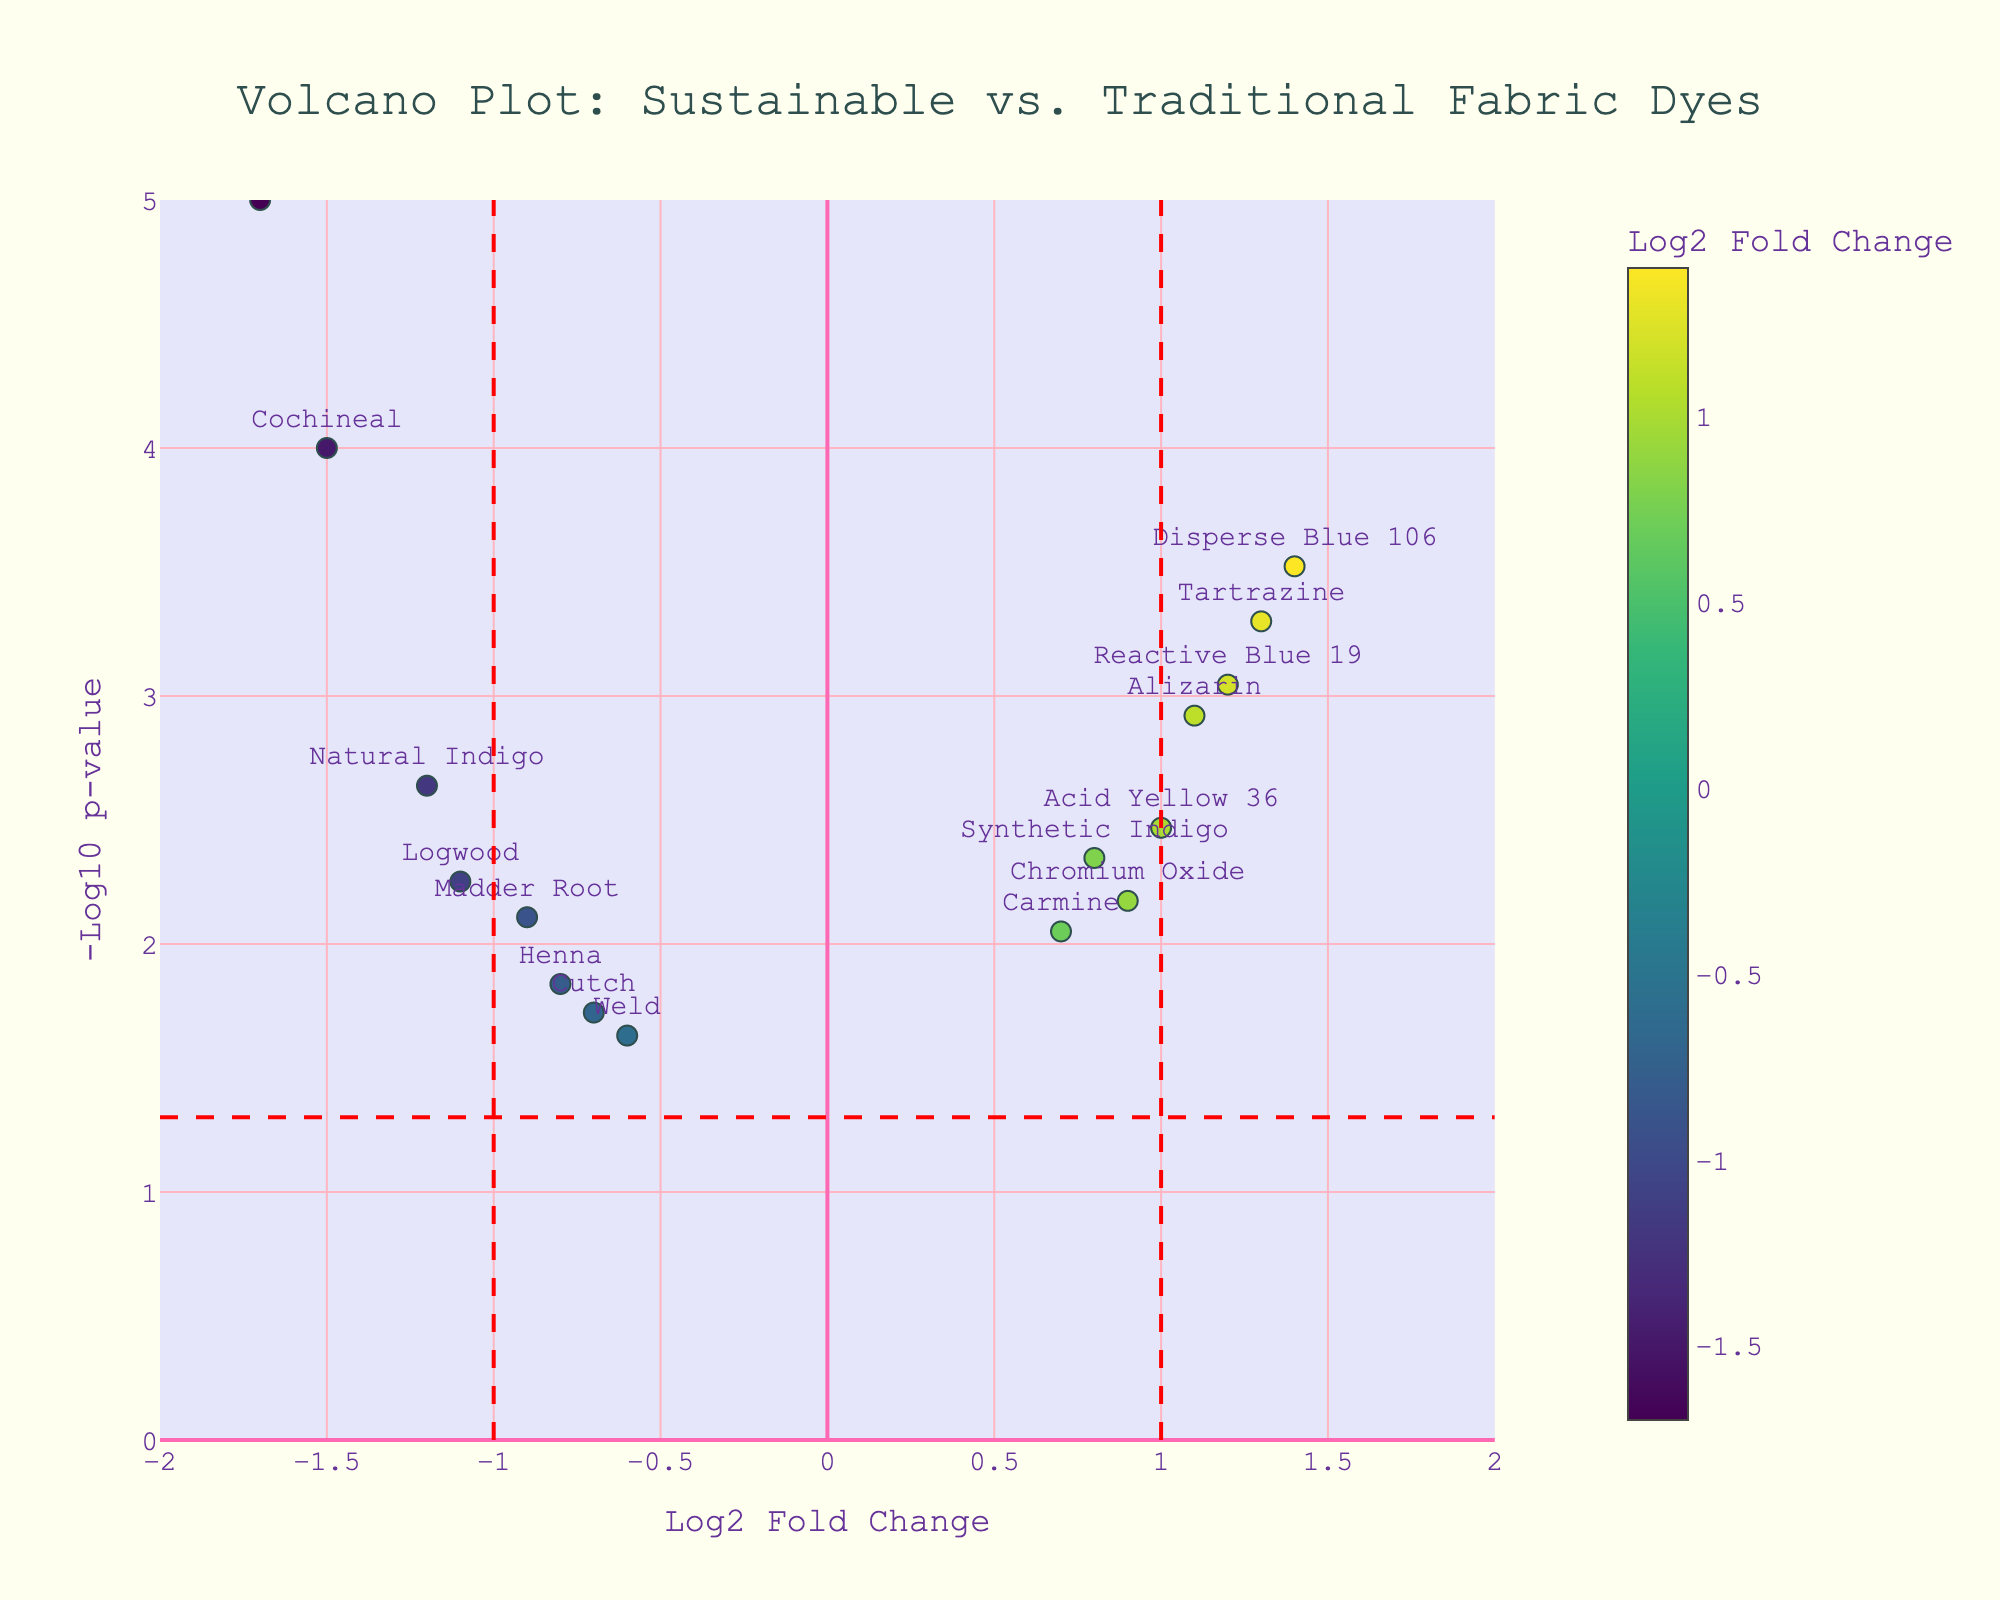Which dye has the highest -log10(p-value)? The highest -log10(p-value) corresponds to the lowest p-value, which is indicated by the highest point on the plot. In this case, it is Cochineal.
Answer: Cochineal How many dyes have a log2 fold change greater than 1? Log2 fold changes greater than 1 are positioned to the right of the vertical line at x = 1. There are four dyes: Alizarin, Tartrazine, Disperse Blue 106, and Reactive Blue 19.
Answer: 4 Which dyes are significantly upregulated (log2 fold change > 1 and p-value < 0.05)? Upregulated dyes have a log2 fold change > 1 (right side of the plot) and a p-value < 0.05 (above the -log10(p-value)=1.3010 threshold). These dyes are Alizarin, Tartrazine, Disperse Blue 106, and Reactive Blue 19.
Answer: Alizarin, Tartrazine, Disperse Blue 106, Reactive Blue 19 Which dye has the lowest log2 fold change? The lowest log2 fold change is the one farthest to the left on the plot, which is Tyrian Purple with a log2 fold change of -1.7.
Answer: Tyrian Purple Are there more dyes upregulated or downregulated? Upregulated dyes (log2 fold change > 0) are on the right side, and downregulated dyes (log2 fold change < 0) are on the left side of the plot. There are 7 upregulated and 8 downregulated dyes.
Answer: Downregulated What is the log2 fold change and p-value for Henna? The log2 fold change and p-value for Henna are displayed directly when hovering over the data point. Henna's log2 fold change is -0.8, and its p-value is 0.0145.
Answer: -0.8, 0.0145 Which dye has the lowest p-value among the significantly downregulated dyes (log2 fold change < -1 and p-value < 0.05)? The lowest p-value among significantly downregulated dyes is indicated by the highest point among those to the far left of the plot (log2 fold change < -1). This is Tyrian Purple with a p-value of 0.00001.
Answer: Tyrian Purple How many dyes have p-values lower than 0.01? Dyes with p-values lower than 0.01 have -log10(p-value) values greater than 2.0000. By examining the plot, there are 9 dyes meeting this criterion: Natural Indigo, Synthetic Indigo, Alizarin, Cochineal, Logwood, Tartrazine, Disperse Blue 106, Tyrian Purple, and Reactive Blue 19.
Answer: 9 